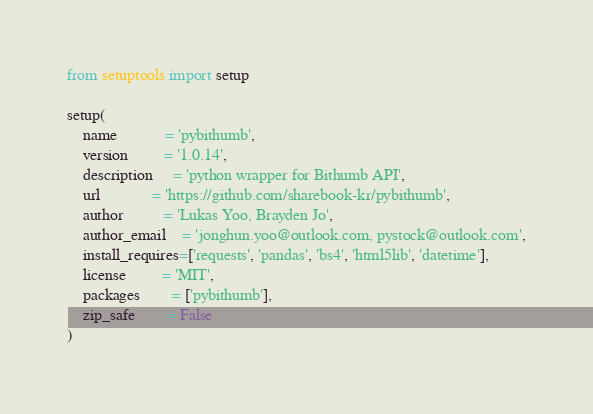Convert code to text. <code><loc_0><loc_0><loc_500><loc_500><_Python_>from setuptools import setup

setup(
    name            = 'pybithumb',
    version         = '1.0.14',
    description     = 'python wrapper for Bithumb API',
    url             = 'https://github.com/sharebook-kr/pybithumb',
    author          = 'Lukas Yoo, Brayden Jo',
    author_email    = 'jonghun.yoo@outlook.com, pystock@outlook.com',
    install_requires=['requests', 'pandas', 'bs4', 'html5lib', 'datetime'],
    license         = 'MIT',
    packages        = ['pybithumb'],
    zip_safe        = False
)</code> 